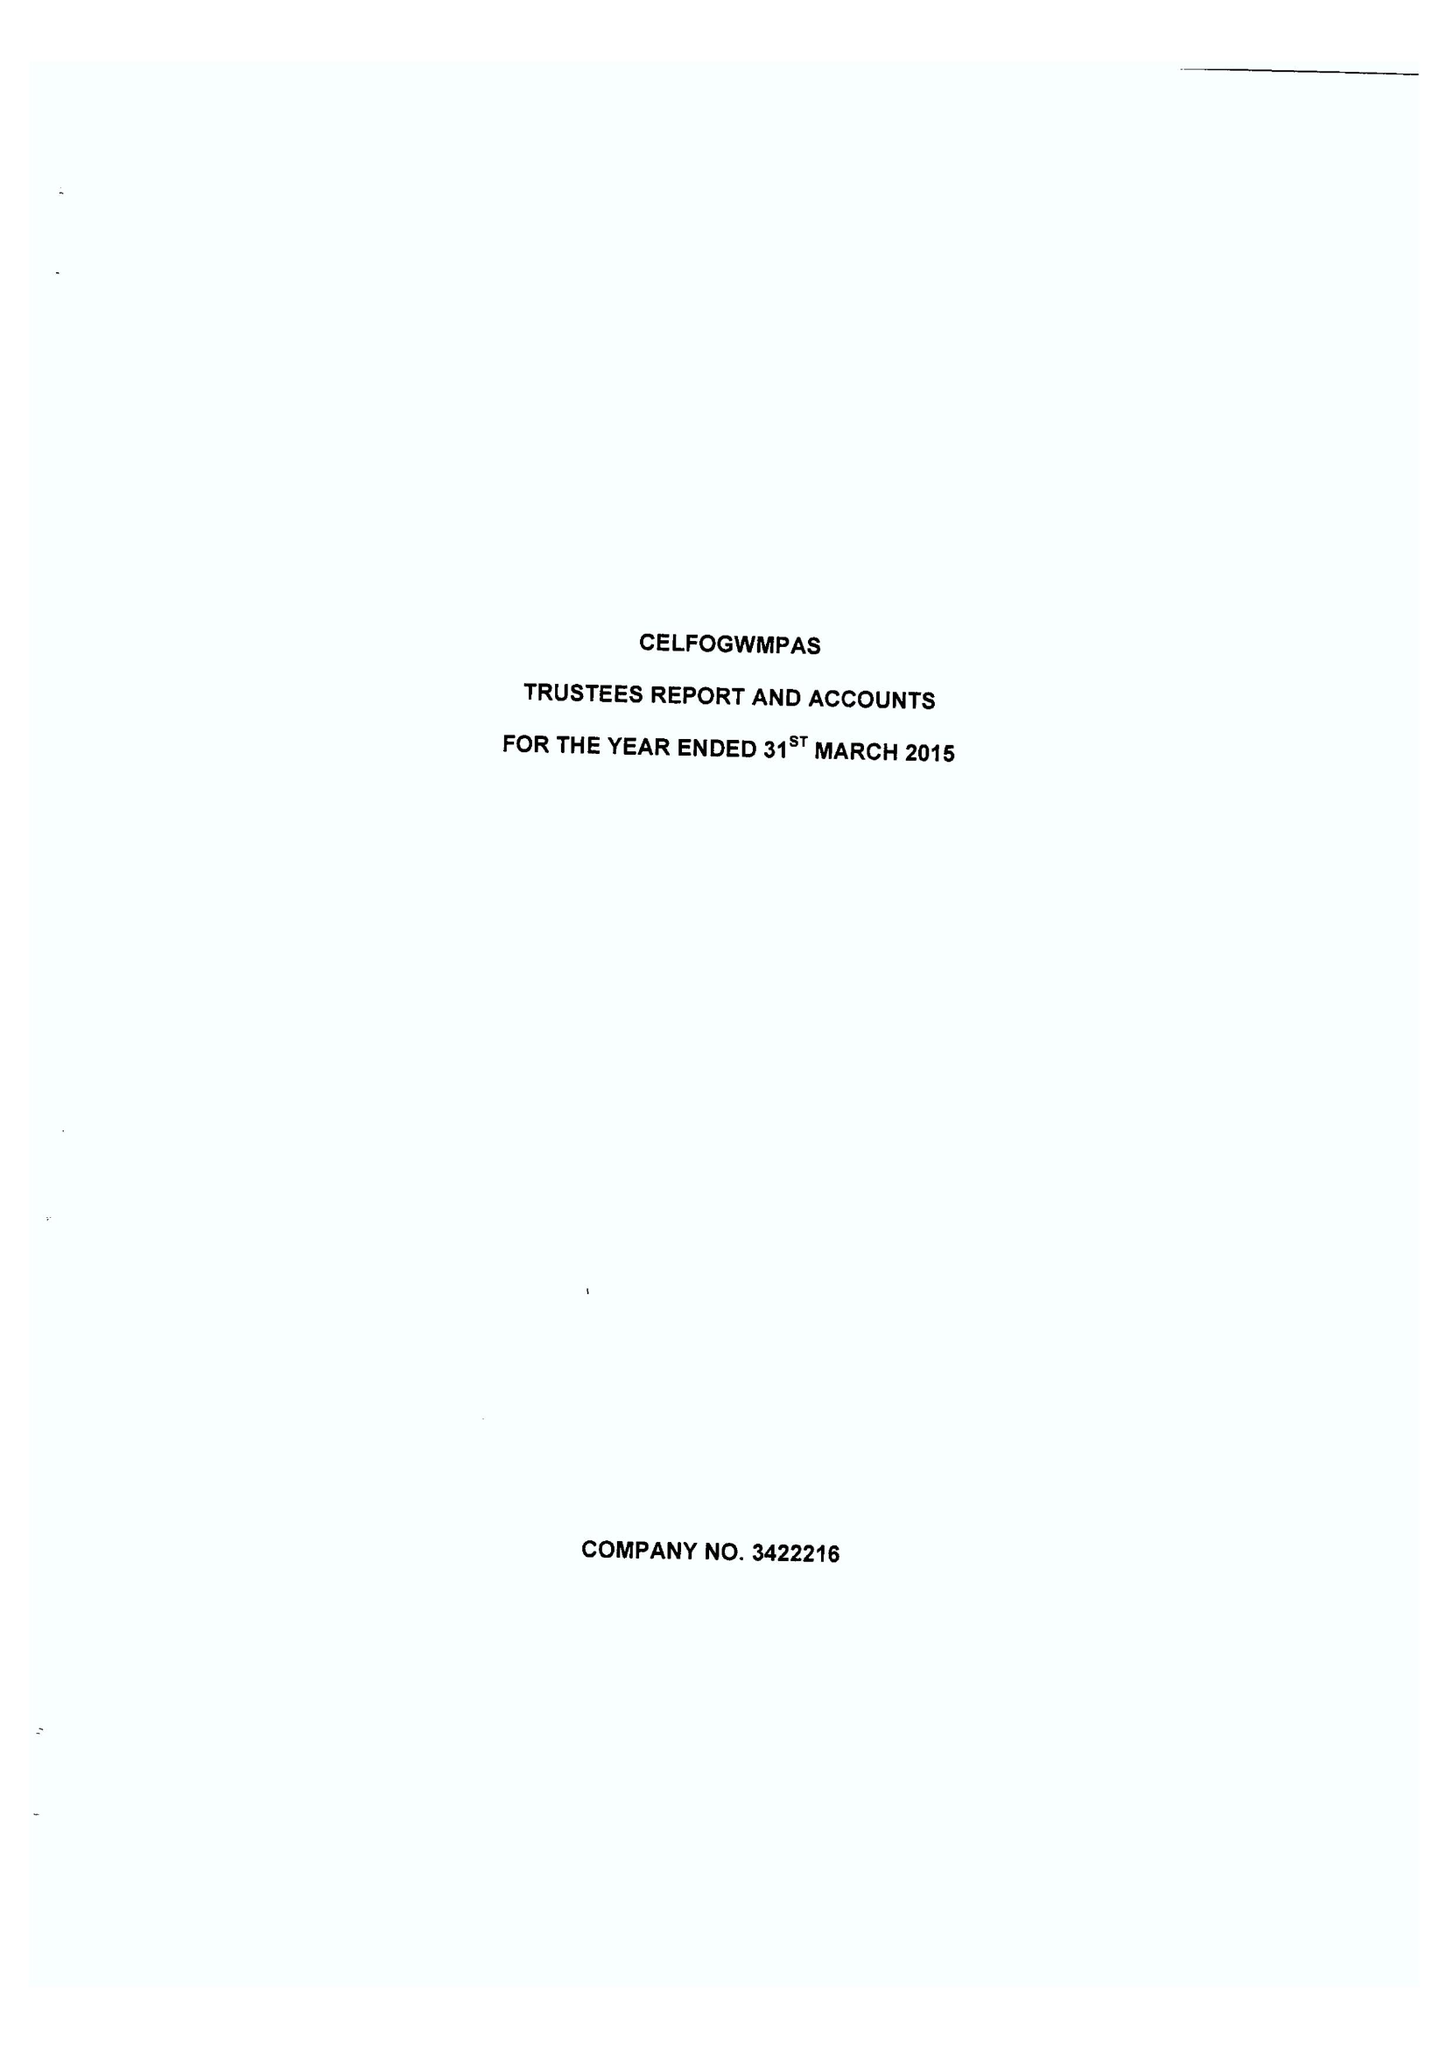What is the value for the income_annually_in_british_pounds?
Answer the question using a single word or phrase. 74277.00 